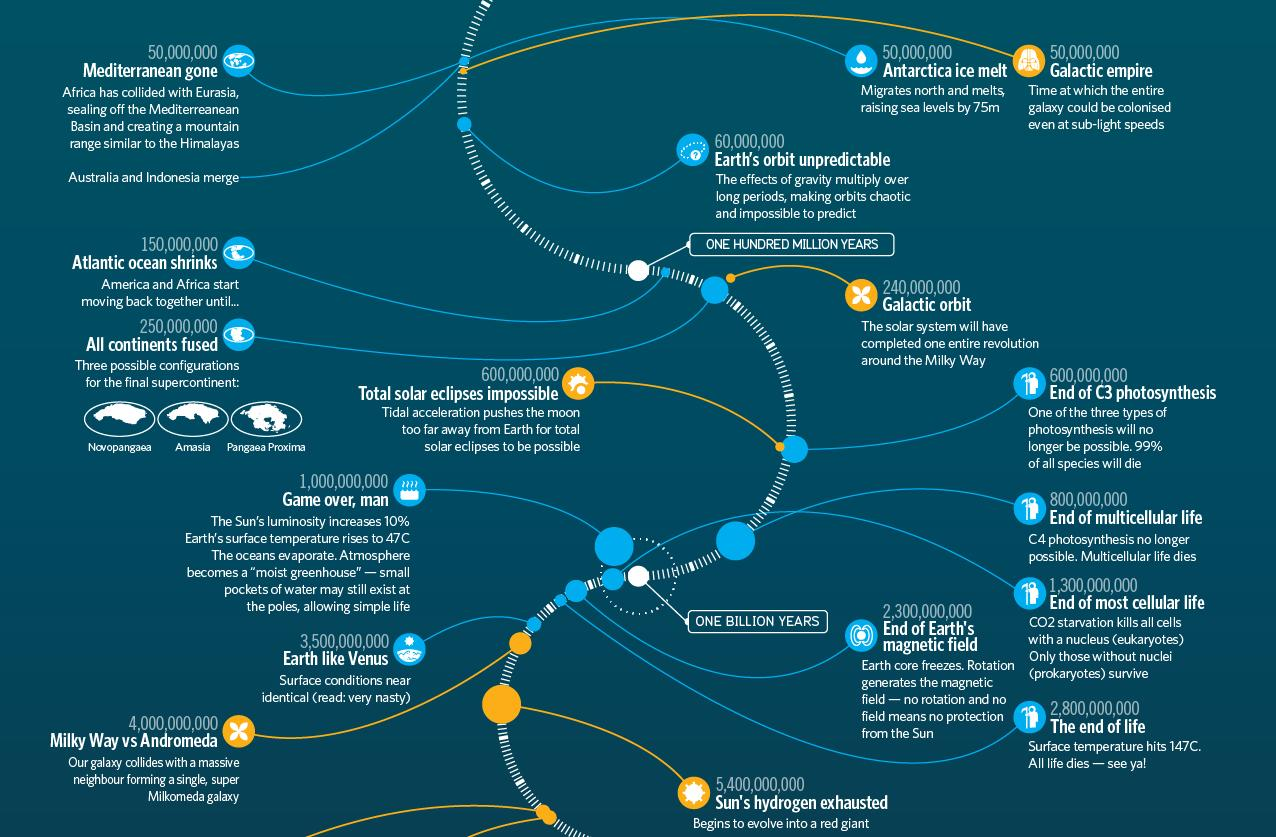Draw attention to some important aspects in this diagram. Earth would resemble Venus towards the end of its life, as Venus exhibits similar characteristics, such as a thick atmosphere and intense heat. The Mediterranean region has disappeared over a period of 50 million years. Approximately 1.3 billion years from now, all forms of cellular life will come to an end. The Milky Way and Andromeda galaxies are set to merge in the future, marking an exciting and unprecedented celestial event. The continents will merge together approximately 250,000,000 years from now. 